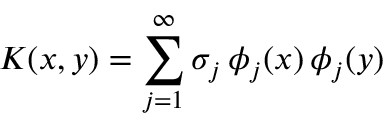<formula> <loc_0><loc_0><loc_500><loc_500>K ( x , y ) = \sum _ { j = 1 } ^ { \infty } \sigma _ { j } \, \phi _ { j } ( x ) \, \phi _ { j } ( y )</formula> 